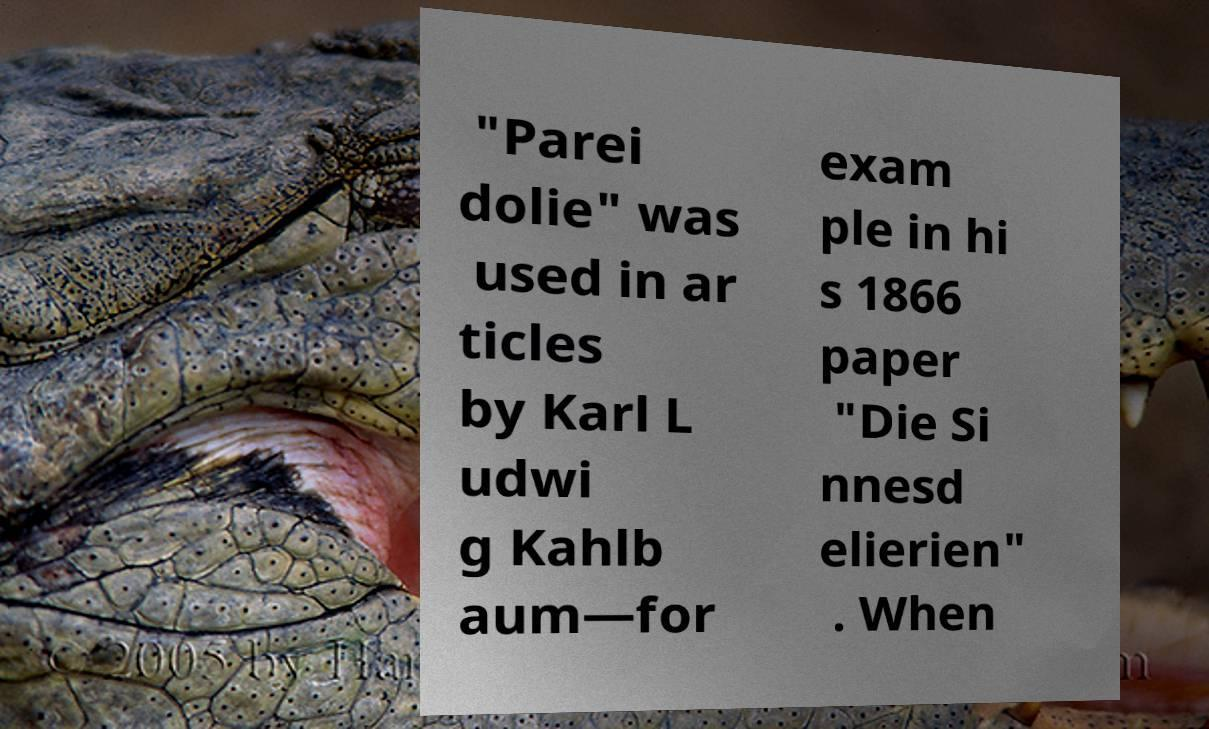Could you assist in decoding the text presented in this image and type it out clearly? "Parei dolie" was used in ar ticles by Karl L udwi g Kahlb aum—for exam ple in hi s 1866 paper "Die Si nnesd elierien" . When 